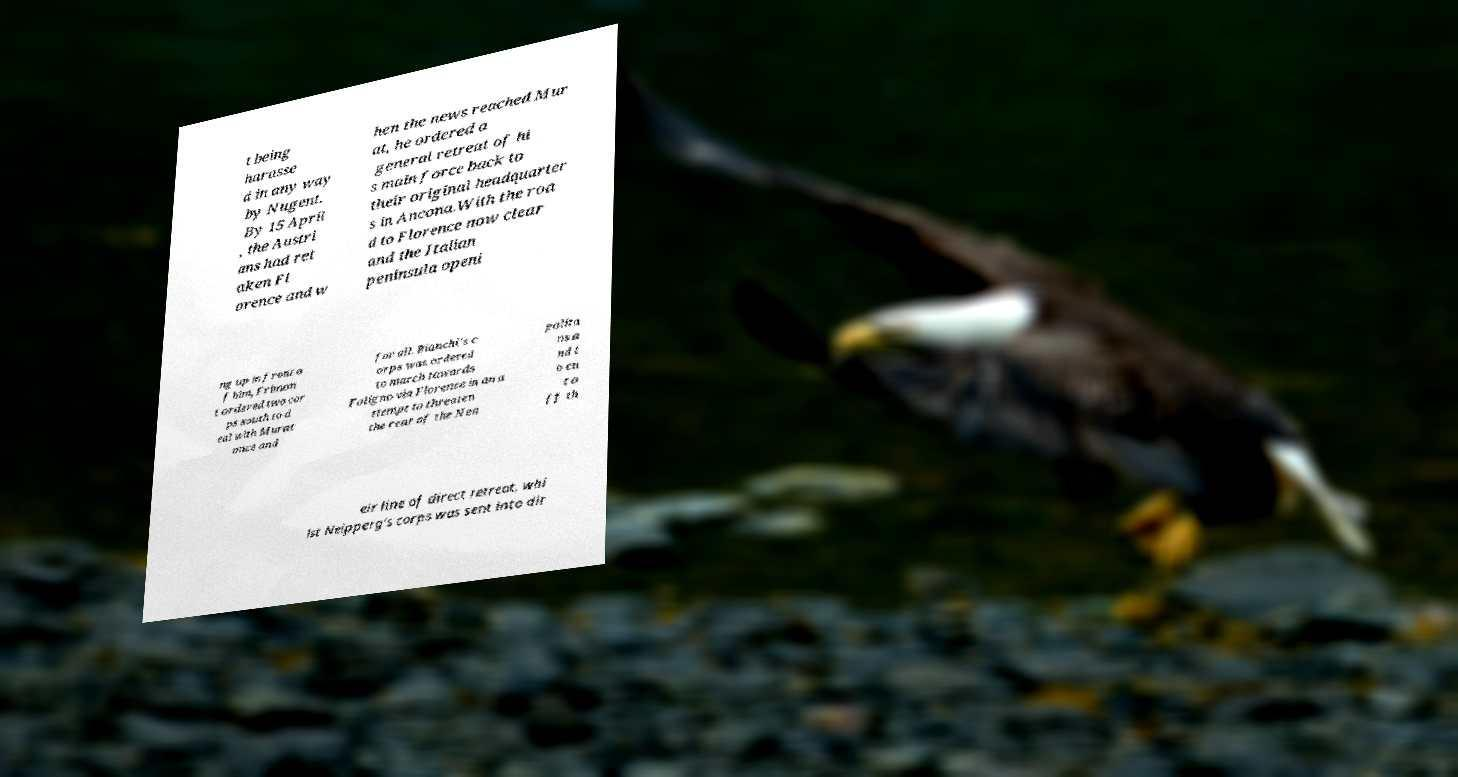Please read and relay the text visible in this image. What does it say? t being harasse d in any way by Nugent. By 15 April , the Austri ans had ret aken Fl orence and w hen the news reached Mur at, he ordered a general retreat of hi s main force back to their original headquarter s in Ancona.With the roa d to Florence now clear and the Italian peninsula openi ng up in front o f him, Frimon t ordered two cor ps south to d eal with Murat once and for all. Bianchi's c orps was ordered to march towards Foligno via Florence in an a ttempt to threaten the rear of the Nea polita ns a nd t o cu t o ff th eir line of direct retreat, whi lst Neipperg's corps was sent into dir 